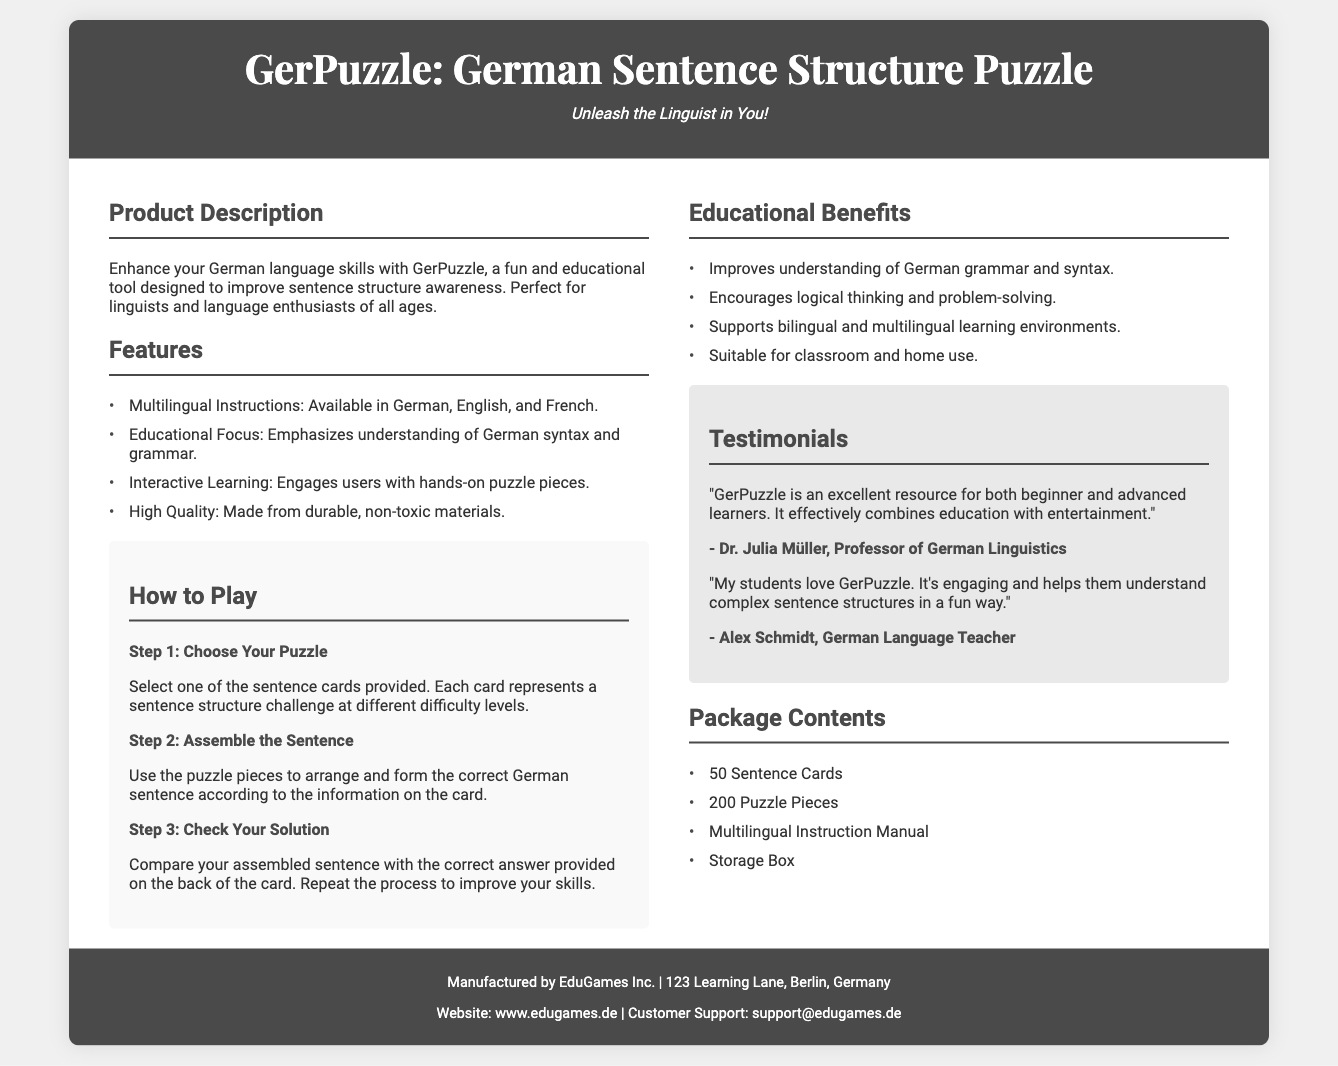What is the name of the product? The name of the product is stated in the header of the document.
Answer: GerPuzzle How many sentence cards are included? The number of sentence cards can be found in the "Package Contents" section of the document.
Answer: 50 Sentence Cards What are the languages in which the instructions are available? The languages for the instructions are listed under the "Features" section.
Answer: German, English, and French Who is the testimonial author that teaches German? The testimonial author who is a German language teacher is mentioned in the testimonials section.
Answer: Alex Schmidt What is the main educational focus of the product? The main educational focus is outlined in the product description.
Answer: Understanding of German syntax and grammar What material are the puzzle pieces made from? The material of the puzzle pieces is mentioned under "Features."
Answer: Durable, non-toxic materials What is one of the educational benefits mentioned? One of the benefits can be found in the "Educational Benefits" section.
Answer: Improves understanding of German grammar and syntax What company manufactured the product? The manufacturer is indicated in the footer section of the document.
Answer: EduGames Inc 